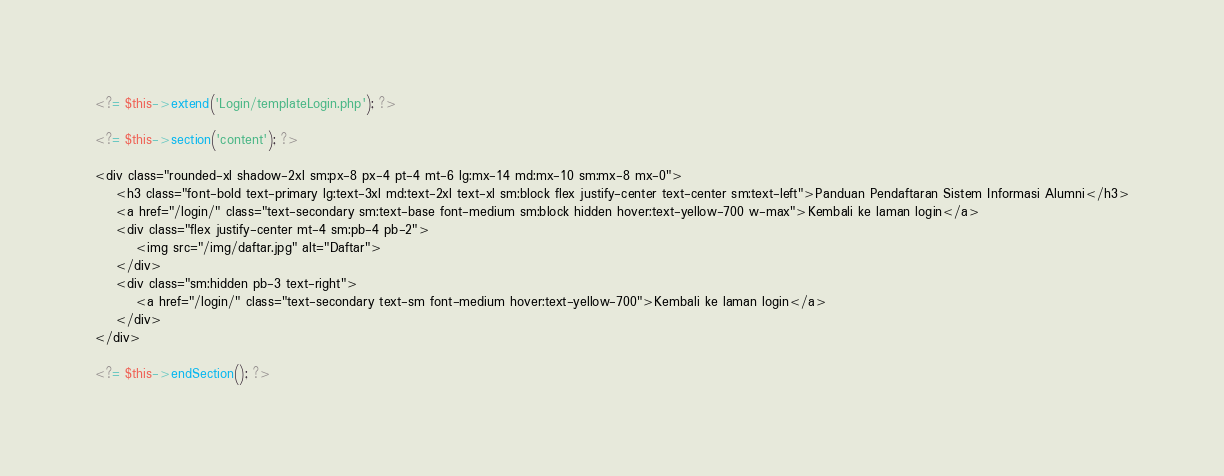Convert code to text. <code><loc_0><loc_0><loc_500><loc_500><_PHP_><?= $this->extend('Login/templateLogin.php'); ?>

<?= $this->section('content'); ?>

<div class="rounded-xl shadow-2xl sm:px-8 px-4 pt-4 mt-6 lg:mx-14 md:mx-10 sm:mx-8 mx-0">
    <h3 class="font-bold text-primary lg:text-3xl md:text-2xl text-xl sm:block flex justify-center text-center sm:text-left">Panduan Pendaftaran Sistem Informasi Alumni</h3>
    <a href="/login/" class="text-secondary sm:text-base font-medium sm:block hidden hover:text-yellow-700 w-max">Kembali ke laman login</a>
    <div class="flex justify-center mt-4 sm:pb-4 pb-2">
        <img src="/img/daftar.jpg" alt="Daftar">
    </div>
    <div class="sm:hidden pb-3 text-right">
        <a href="/login/" class="text-secondary text-sm font-medium hover:text-yellow-700">Kembali ke laman login</a>
    </div>
</div>

<?= $this->endSection(); ?></code> 